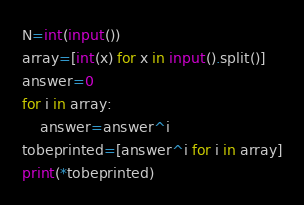<code> <loc_0><loc_0><loc_500><loc_500><_Python_>N=int(input())
array=[int(x) for x in input().split()]
answer=0
for i in array:
	answer=answer^i
tobeprinted=[answer^i for i in array]
print(*tobeprinted)</code> 